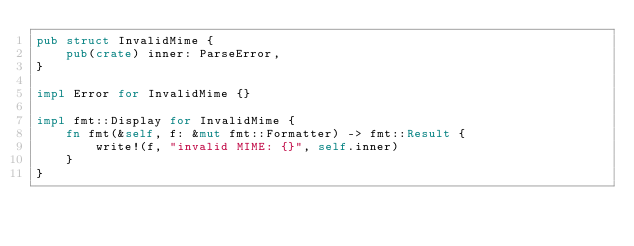Convert code to text. <code><loc_0><loc_0><loc_500><loc_500><_Rust_>pub struct InvalidMime {
    pub(crate) inner: ParseError,
}

impl Error for InvalidMime {}

impl fmt::Display for InvalidMime {
    fn fmt(&self, f: &mut fmt::Formatter) -> fmt::Result {
        write!(f, "invalid MIME: {}", self.inner)
    }
}
</code> 